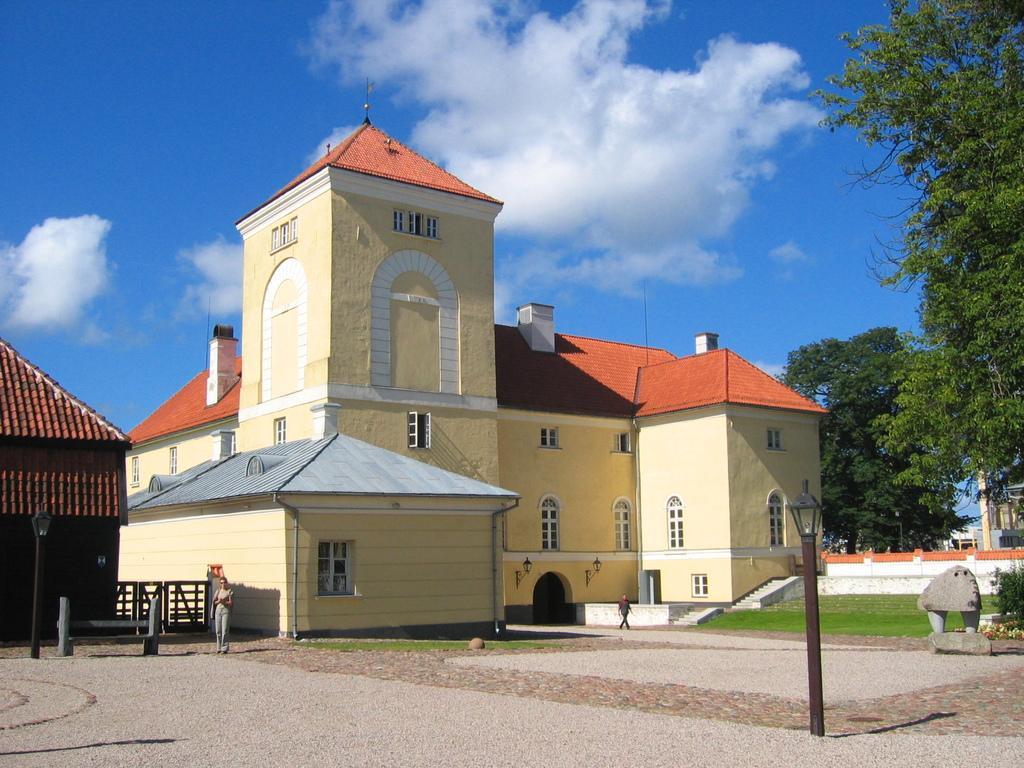How would you summarize this image in a sentence or two? In this image we can see a building with windows, roof, staircase and a fence. We can also see some street lamps, poles, some people standing, a statue and some grass on the ground. We can also see a group of trees, plants and the sky which looks cloudy. On the left side we can see a house with a roof. 